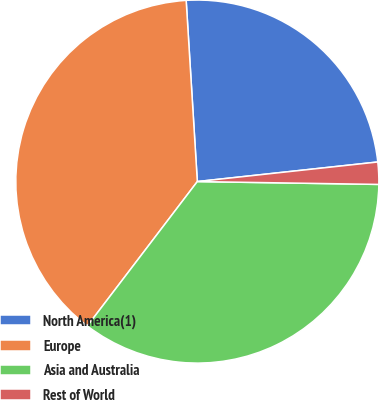Convert chart. <chart><loc_0><loc_0><loc_500><loc_500><pie_chart><fcel>North America(1)<fcel>Europe<fcel>Asia and Australia<fcel>Rest of World<nl><fcel>24.26%<fcel>38.66%<fcel>35.11%<fcel>1.97%<nl></chart> 